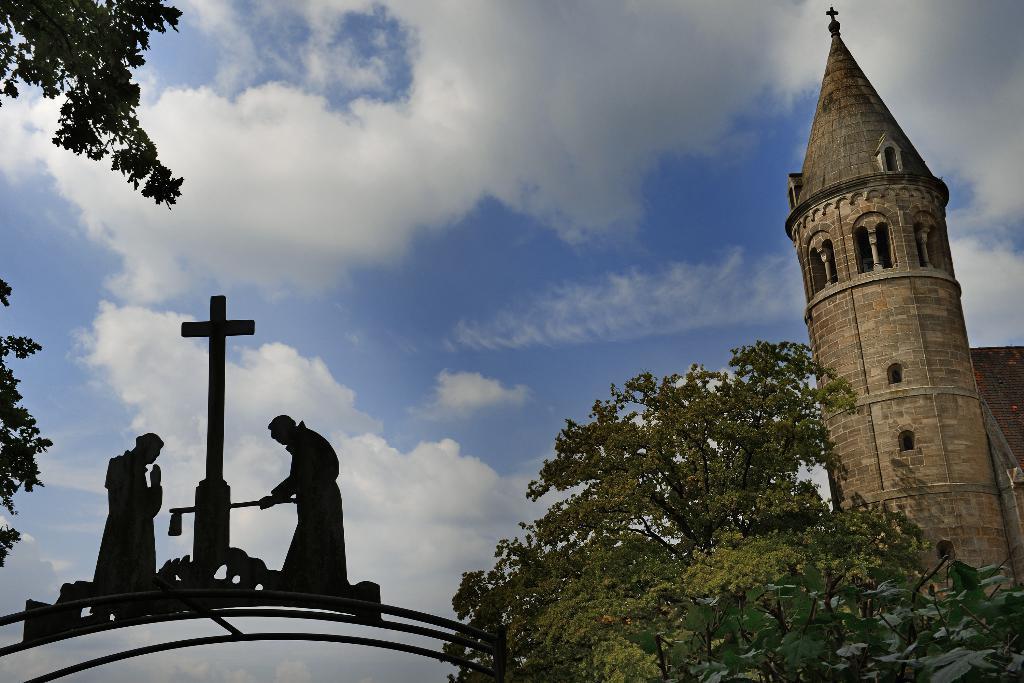Describe this image in one or two sentences. On the right side, we see a castle or a church. At the bottom, we see the trees. In the left bottom, we see the statues and a crucifix. On the left side, we see the trees. In the background, we see the clouds and the sky, which is blue in color. 